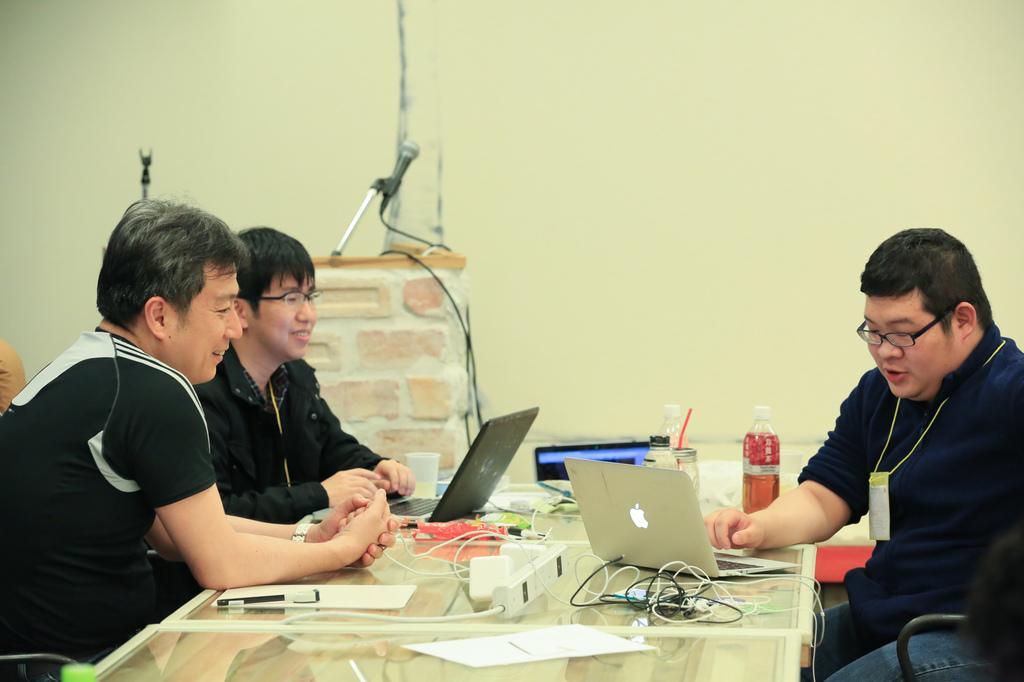Please provide a concise description of this image. This is the picture of a room. In this image there are group of people sitting and smiling. There are laptops, devices, bottles, glasses, papers and wires on the table. At the back there is a microphone. At the back there is a wall. 